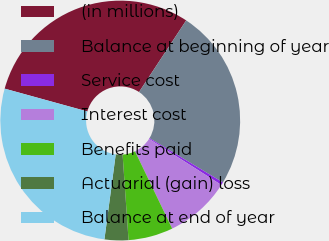Convert chart. <chart><loc_0><loc_0><loc_500><loc_500><pie_chart><fcel>(in millions)<fcel>Balance at beginning of year<fcel>Service cost<fcel>Interest cost<fcel>Benefits paid<fcel>Actuarial (gain) loss<fcel>Balance at end of year<nl><fcel>29.99%<fcel>24.36%<fcel>0.4%<fcel>8.84%<fcel>6.03%<fcel>3.21%<fcel>27.18%<nl></chart> 